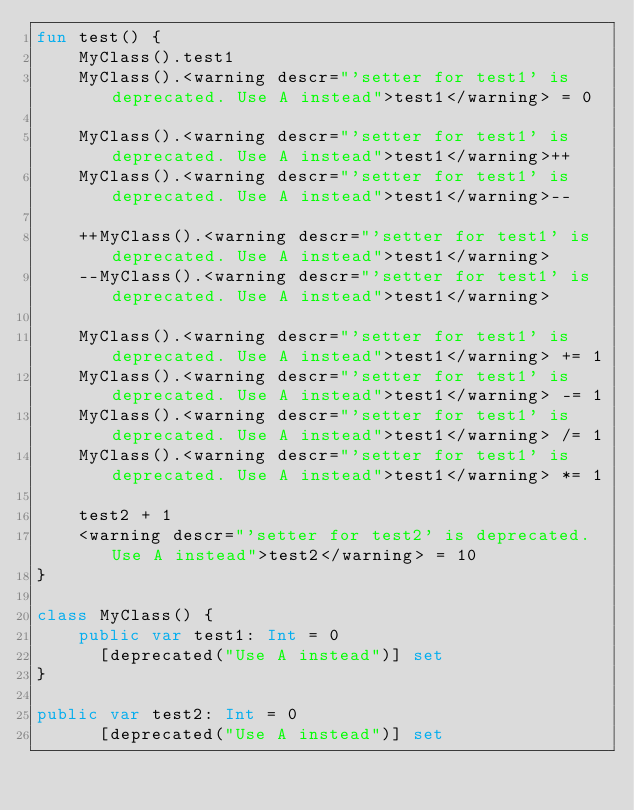Convert code to text. <code><loc_0><loc_0><loc_500><loc_500><_Kotlin_>fun test() {
    MyClass().test1
    MyClass().<warning descr="'setter for test1' is deprecated. Use A instead">test1</warning> = 0

    MyClass().<warning descr="'setter for test1' is deprecated. Use A instead">test1</warning>++
    MyClass().<warning descr="'setter for test1' is deprecated. Use A instead">test1</warning>--

    ++MyClass().<warning descr="'setter for test1' is deprecated. Use A instead">test1</warning>
    --MyClass().<warning descr="'setter for test1' is deprecated. Use A instead">test1</warning>

    MyClass().<warning descr="'setter for test1' is deprecated. Use A instead">test1</warning> += 1
    MyClass().<warning descr="'setter for test1' is deprecated. Use A instead">test1</warning> -= 1
    MyClass().<warning descr="'setter for test1' is deprecated. Use A instead">test1</warning> /= 1
    MyClass().<warning descr="'setter for test1' is deprecated. Use A instead">test1</warning> *= 1

    test2 + 1
    <warning descr="'setter for test2' is deprecated. Use A instead">test2</warning> = 10
}

class MyClass() {
    public var test1: Int = 0
      [deprecated("Use A instead")] set
}

public var test2: Int = 0
      [deprecated("Use A instead")] set</code> 